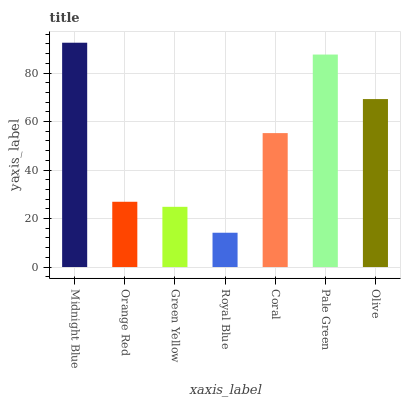Is Royal Blue the minimum?
Answer yes or no. Yes. Is Midnight Blue the maximum?
Answer yes or no. Yes. Is Orange Red the minimum?
Answer yes or no. No. Is Orange Red the maximum?
Answer yes or no. No. Is Midnight Blue greater than Orange Red?
Answer yes or no. Yes. Is Orange Red less than Midnight Blue?
Answer yes or no. Yes. Is Orange Red greater than Midnight Blue?
Answer yes or no. No. Is Midnight Blue less than Orange Red?
Answer yes or no. No. Is Coral the high median?
Answer yes or no. Yes. Is Coral the low median?
Answer yes or no. Yes. Is Pale Green the high median?
Answer yes or no. No. Is Royal Blue the low median?
Answer yes or no. No. 